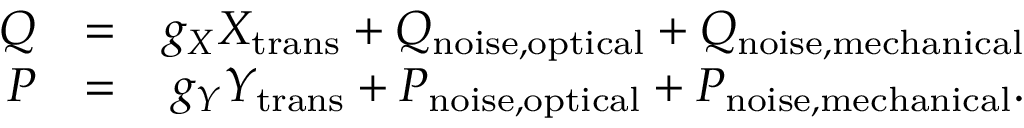<formula> <loc_0><loc_0><loc_500><loc_500>\begin{array} { r l r } { Q } & { = } & { g _ { X } X _ { t r a n s } + Q _ { n o i s e , o p t i c a l } + Q _ { n o i s e , m e c h a n i c a l } } \\ { P } & { = } & { g _ { Y } Y _ { t r a n s } + P _ { n o i s e , o p t i c a l } + P _ { n o i s e , m e c h a n i c a l } . } \end{array}</formula> 